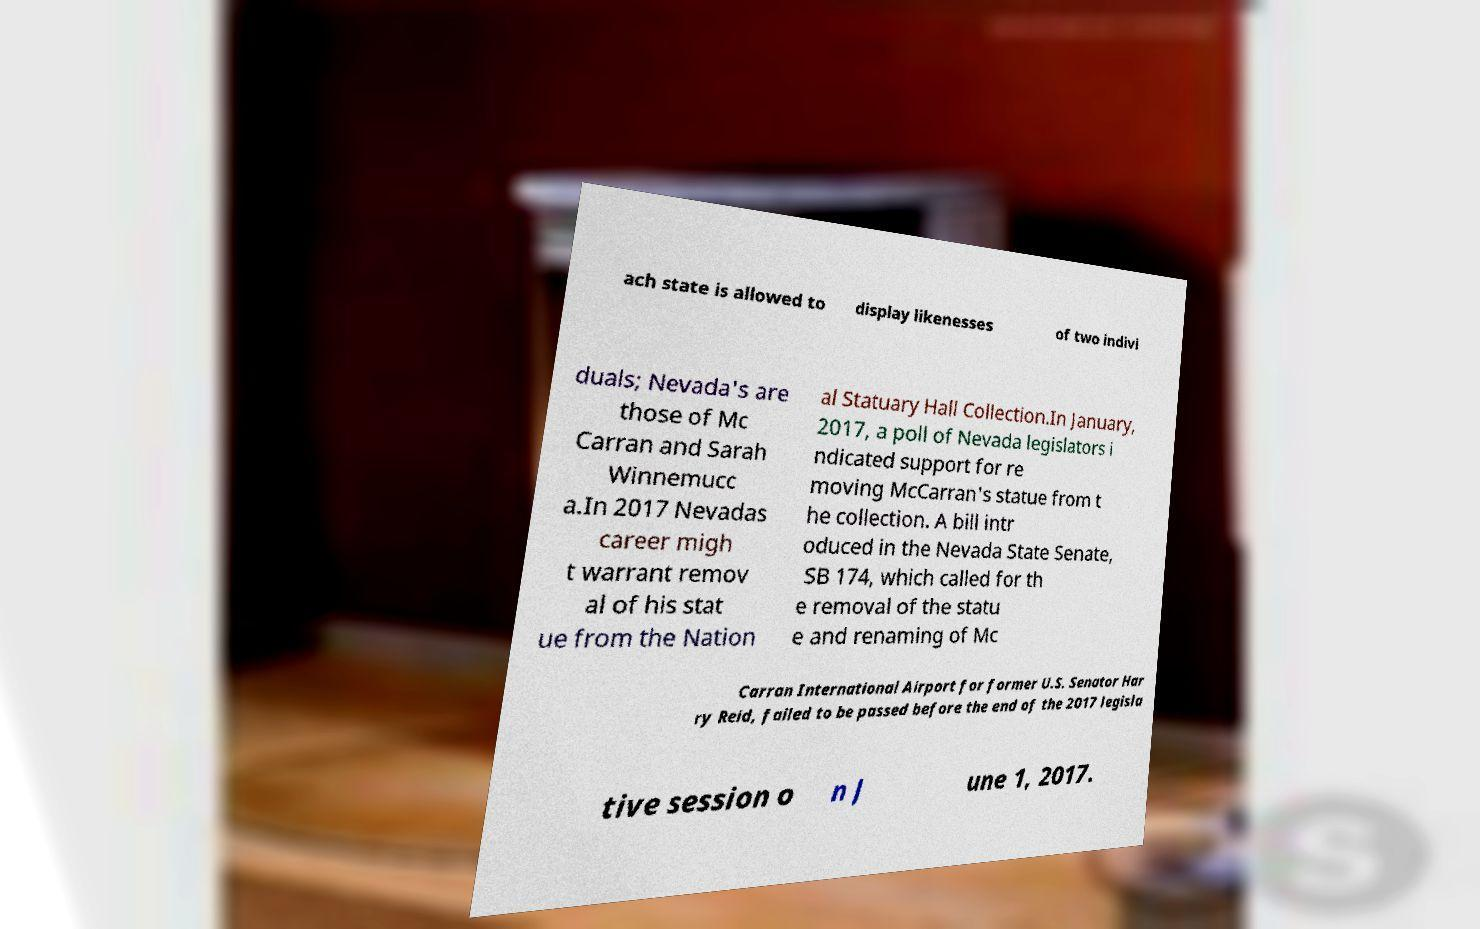Can you accurately transcribe the text from the provided image for me? ach state is allowed to display likenesses of two indivi duals; Nevada's are those of Mc Carran and Sarah Winnemucc a.In 2017 Nevadas career migh t warrant remov al of his stat ue from the Nation al Statuary Hall Collection.In January, 2017, a poll of Nevada legislators i ndicated support for re moving McCarran's statue from t he collection. A bill intr oduced in the Nevada State Senate, SB 174, which called for th e removal of the statu e and renaming of Mc Carran International Airport for former U.S. Senator Har ry Reid, failed to be passed before the end of the 2017 legisla tive session o n J une 1, 2017. 